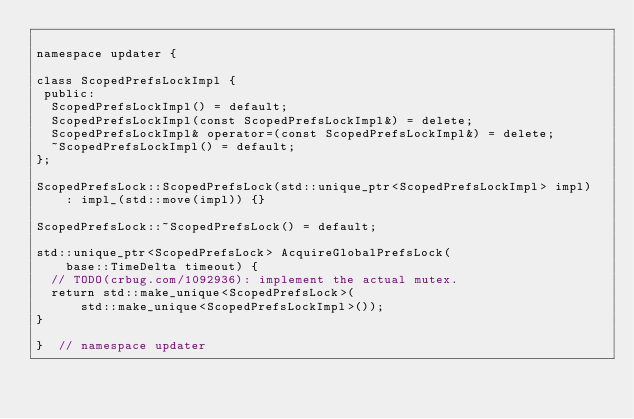Convert code to text. <code><loc_0><loc_0><loc_500><loc_500><_ObjectiveC_>
namespace updater {

class ScopedPrefsLockImpl {
 public:
  ScopedPrefsLockImpl() = default;
  ScopedPrefsLockImpl(const ScopedPrefsLockImpl&) = delete;
  ScopedPrefsLockImpl& operator=(const ScopedPrefsLockImpl&) = delete;
  ~ScopedPrefsLockImpl() = default;
};

ScopedPrefsLock::ScopedPrefsLock(std::unique_ptr<ScopedPrefsLockImpl> impl)
    : impl_(std::move(impl)) {}

ScopedPrefsLock::~ScopedPrefsLock() = default;

std::unique_ptr<ScopedPrefsLock> AcquireGlobalPrefsLock(
    base::TimeDelta timeout) {
  // TODO(crbug.com/1092936): implement the actual mutex.
  return std::make_unique<ScopedPrefsLock>(
      std::make_unique<ScopedPrefsLockImpl>());
}

}  // namespace updater
</code> 